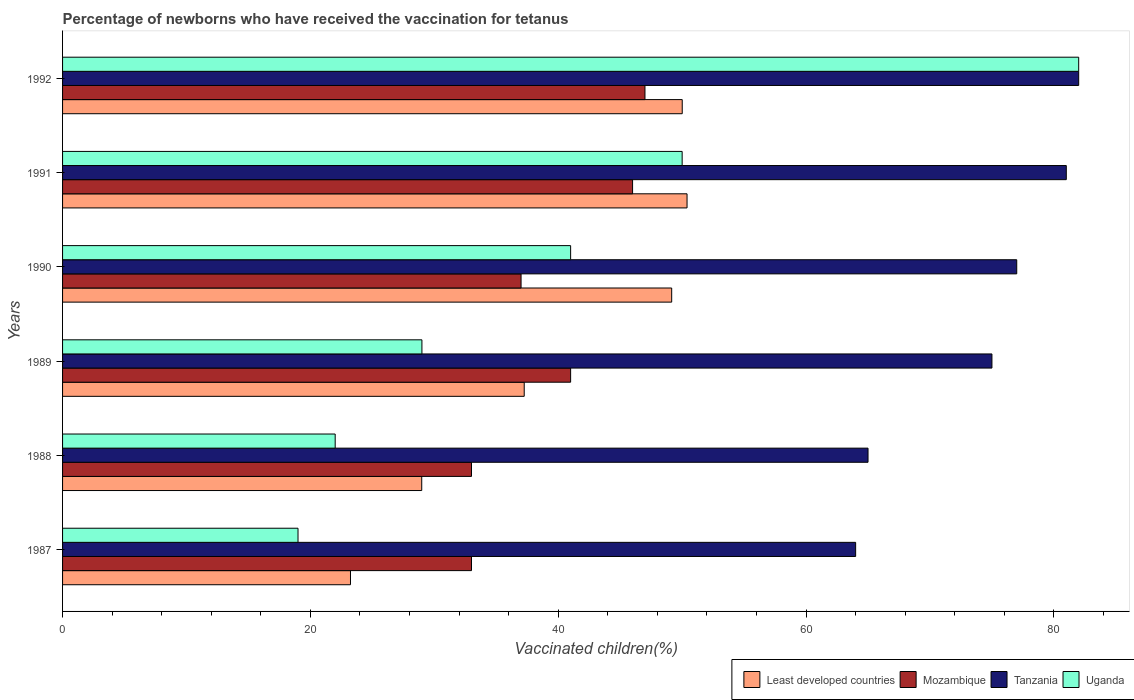Are the number of bars per tick equal to the number of legend labels?
Provide a short and direct response. Yes. Are the number of bars on each tick of the Y-axis equal?
Provide a succinct answer. Yes. How many bars are there on the 2nd tick from the bottom?
Make the answer very short. 4. What is the percentage of vaccinated children in Mozambique in 1988?
Offer a very short reply. 33. Across all years, what is the maximum percentage of vaccinated children in Least developed countries?
Provide a short and direct response. 50.39. Across all years, what is the minimum percentage of vaccinated children in Least developed countries?
Make the answer very short. 23.23. What is the total percentage of vaccinated children in Tanzania in the graph?
Keep it short and to the point. 444. What is the difference between the percentage of vaccinated children in Least developed countries in 1988 and that in 1989?
Keep it short and to the point. -8.27. What is the difference between the percentage of vaccinated children in Tanzania in 1988 and the percentage of vaccinated children in Least developed countries in 1989?
Give a very brief answer. 27.75. What is the average percentage of vaccinated children in Least developed countries per year?
Provide a succinct answer. 39.84. In the year 1990, what is the difference between the percentage of vaccinated children in Mozambique and percentage of vaccinated children in Uganda?
Provide a short and direct response. -4. What is the ratio of the percentage of vaccinated children in Mozambique in 1988 to that in 1992?
Offer a very short reply. 0.7. Is the percentage of vaccinated children in Tanzania in 1987 less than that in 1992?
Your answer should be compact. Yes. Is the difference between the percentage of vaccinated children in Mozambique in 1988 and 1992 greater than the difference between the percentage of vaccinated children in Uganda in 1988 and 1992?
Provide a short and direct response. Yes. What is the difference between the highest and the second highest percentage of vaccinated children in Least developed countries?
Provide a succinct answer. 0.39. What is the difference between the highest and the lowest percentage of vaccinated children in Tanzania?
Offer a terse response. 18. Is the sum of the percentage of vaccinated children in Uganda in 1990 and 1992 greater than the maximum percentage of vaccinated children in Tanzania across all years?
Your response must be concise. Yes. What does the 2nd bar from the top in 1990 represents?
Provide a succinct answer. Tanzania. What does the 3rd bar from the bottom in 1990 represents?
Your answer should be very brief. Tanzania. Is it the case that in every year, the sum of the percentage of vaccinated children in Tanzania and percentage of vaccinated children in Mozambique is greater than the percentage of vaccinated children in Least developed countries?
Provide a short and direct response. Yes. How many bars are there?
Your answer should be very brief. 24. How many legend labels are there?
Your answer should be very brief. 4. What is the title of the graph?
Offer a terse response. Percentage of newborns who have received the vaccination for tetanus. Does "Faeroe Islands" appear as one of the legend labels in the graph?
Ensure brevity in your answer.  No. What is the label or title of the X-axis?
Ensure brevity in your answer.  Vaccinated children(%). What is the Vaccinated children(%) of Least developed countries in 1987?
Offer a terse response. 23.23. What is the Vaccinated children(%) in Mozambique in 1987?
Your answer should be very brief. 33. What is the Vaccinated children(%) in Tanzania in 1987?
Provide a succinct answer. 64. What is the Vaccinated children(%) in Least developed countries in 1988?
Provide a short and direct response. 28.98. What is the Vaccinated children(%) of Mozambique in 1988?
Provide a short and direct response. 33. What is the Vaccinated children(%) in Tanzania in 1988?
Your response must be concise. 65. What is the Vaccinated children(%) of Least developed countries in 1989?
Ensure brevity in your answer.  37.25. What is the Vaccinated children(%) of Tanzania in 1989?
Make the answer very short. 75. What is the Vaccinated children(%) in Least developed countries in 1990?
Give a very brief answer. 49.16. What is the Vaccinated children(%) of Mozambique in 1990?
Your response must be concise. 37. What is the Vaccinated children(%) in Tanzania in 1990?
Make the answer very short. 77. What is the Vaccinated children(%) of Uganda in 1990?
Your response must be concise. 41. What is the Vaccinated children(%) in Least developed countries in 1991?
Ensure brevity in your answer.  50.39. What is the Vaccinated children(%) of Mozambique in 1991?
Your response must be concise. 46. What is the Vaccinated children(%) in Tanzania in 1991?
Provide a short and direct response. 81. What is the Vaccinated children(%) of Uganda in 1991?
Your answer should be compact. 50. What is the Vaccinated children(%) of Least developed countries in 1992?
Give a very brief answer. 50.01. What is the Vaccinated children(%) in Mozambique in 1992?
Ensure brevity in your answer.  47. What is the Vaccinated children(%) in Tanzania in 1992?
Ensure brevity in your answer.  82. Across all years, what is the maximum Vaccinated children(%) of Least developed countries?
Your response must be concise. 50.39. Across all years, what is the maximum Vaccinated children(%) of Mozambique?
Your response must be concise. 47. Across all years, what is the maximum Vaccinated children(%) of Tanzania?
Offer a very short reply. 82. Across all years, what is the minimum Vaccinated children(%) in Least developed countries?
Your response must be concise. 23.23. Across all years, what is the minimum Vaccinated children(%) of Mozambique?
Offer a terse response. 33. Across all years, what is the minimum Vaccinated children(%) of Tanzania?
Your answer should be compact. 64. What is the total Vaccinated children(%) in Least developed countries in the graph?
Ensure brevity in your answer.  239.03. What is the total Vaccinated children(%) of Mozambique in the graph?
Offer a terse response. 237. What is the total Vaccinated children(%) in Tanzania in the graph?
Offer a terse response. 444. What is the total Vaccinated children(%) in Uganda in the graph?
Provide a succinct answer. 243. What is the difference between the Vaccinated children(%) of Least developed countries in 1987 and that in 1988?
Offer a terse response. -5.75. What is the difference between the Vaccinated children(%) of Mozambique in 1987 and that in 1988?
Your response must be concise. 0. What is the difference between the Vaccinated children(%) of Tanzania in 1987 and that in 1988?
Make the answer very short. -1. What is the difference between the Vaccinated children(%) of Least developed countries in 1987 and that in 1989?
Your answer should be compact. -14.02. What is the difference between the Vaccinated children(%) in Uganda in 1987 and that in 1989?
Provide a short and direct response. -10. What is the difference between the Vaccinated children(%) of Least developed countries in 1987 and that in 1990?
Make the answer very short. -25.92. What is the difference between the Vaccinated children(%) in Uganda in 1987 and that in 1990?
Make the answer very short. -22. What is the difference between the Vaccinated children(%) in Least developed countries in 1987 and that in 1991?
Provide a succinct answer. -27.16. What is the difference between the Vaccinated children(%) of Mozambique in 1987 and that in 1991?
Provide a short and direct response. -13. What is the difference between the Vaccinated children(%) in Tanzania in 1987 and that in 1991?
Your response must be concise. -17. What is the difference between the Vaccinated children(%) in Uganda in 1987 and that in 1991?
Make the answer very short. -31. What is the difference between the Vaccinated children(%) of Least developed countries in 1987 and that in 1992?
Ensure brevity in your answer.  -26.77. What is the difference between the Vaccinated children(%) of Mozambique in 1987 and that in 1992?
Give a very brief answer. -14. What is the difference between the Vaccinated children(%) of Tanzania in 1987 and that in 1992?
Your answer should be compact. -18. What is the difference between the Vaccinated children(%) in Uganda in 1987 and that in 1992?
Ensure brevity in your answer.  -63. What is the difference between the Vaccinated children(%) of Least developed countries in 1988 and that in 1989?
Keep it short and to the point. -8.27. What is the difference between the Vaccinated children(%) in Least developed countries in 1988 and that in 1990?
Make the answer very short. -20.17. What is the difference between the Vaccinated children(%) in Least developed countries in 1988 and that in 1991?
Ensure brevity in your answer.  -21.41. What is the difference between the Vaccinated children(%) of Mozambique in 1988 and that in 1991?
Offer a terse response. -13. What is the difference between the Vaccinated children(%) of Tanzania in 1988 and that in 1991?
Provide a short and direct response. -16. What is the difference between the Vaccinated children(%) in Uganda in 1988 and that in 1991?
Ensure brevity in your answer.  -28. What is the difference between the Vaccinated children(%) in Least developed countries in 1988 and that in 1992?
Provide a short and direct response. -21.02. What is the difference between the Vaccinated children(%) in Uganda in 1988 and that in 1992?
Your answer should be very brief. -60. What is the difference between the Vaccinated children(%) of Least developed countries in 1989 and that in 1990?
Keep it short and to the point. -11.9. What is the difference between the Vaccinated children(%) of Tanzania in 1989 and that in 1990?
Offer a very short reply. -2. What is the difference between the Vaccinated children(%) of Least developed countries in 1989 and that in 1991?
Offer a terse response. -13.14. What is the difference between the Vaccinated children(%) of Tanzania in 1989 and that in 1991?
Your response must be concise. -6. What is the difference between the Vaccinated children(%) of Least developed countries in 1989 and that in 1992?
Provide a short and direct response. -12.75. What is the difference between the Vaccinated children(%) of Mozambique in 1989 and that in 1992?
Provide a short and direct response. -6. What is the difference between the Vaccinated children(%) in Uganda in 1989 and that in 1992?
Ensure brevity in your answer.  -53. What is the difference between the Vaccinated children(%) of Least developed countries in 1990 and that in 1991?
Provide a succinct answer. -1.24. What is the difference between the Vaccinated children(%) of Mozambique in 1990 and that in 1991?
Give a very brief answer. -9. What is the difference between the Vaccinated children(%) of Tanzania in 1990 and that in 1991?
Your answer should be compact. -4. What is the difference between the Vaccinated children(%) in Least developed countries in 1990 and that in 1992?
Your answer should be very brief. -0.85. What is the difference between the Vaccinated children(%) of Mozambique in 1990 and that in 1992?
Ensure brevity in your answer.  -10. What is the difference between the Vaccinated children(%) of Uganda in 1990 and that in 1992?
Offer a very short reply. -41. What is the difference between the Vaccinated children(%) in Least developed countries in 1991 and that in 1992?
Your response must be concise. 0.39. What is the difference between the Vaccinated children(%) in Tanzania in 1991 and that in 1992?
Make the answer very short. -1. What is the difference between the Vaccinated children(%) in Uganda in 1991 and that in 1992?
Ensure brevity in your answer.  -32. What is the difference between the Vaccinated children(%) in Least developed countries in 1987 and the Vaccinated children(%) in Mozambique in 1988?
Ensure brevity in your answer.  -9.77. What is the difference between the Vaccinated children(%) in Least developed countries in 1987 and the Vaccinated children(%) in Tanzania in 1988?
Offer a very short reply. -41.77. What is the difference between the Vaccinated children(%) of Least developed countries in 1987 and the Vaccinated children(%) of Uganda in 1988?
Provide a succinct answer. 1.23. What is the difference between the Vaccinated children(%) in Mozambique in 1987 and the Vaccinated children(%) in Tanzania in 1988?
Your response must be concise. -32. What is the difference between the Vaccinated children(%) of Mozambique in 1987 and the Vaccinated children(%) of Uganda in 1988?
Your response must be concise. 11. What is the difference between the Vaccinated children(%) in Tanzania in 1987 and the Vaccinated children(%) in Uganda in 1988?
Make the answer very short. 42. What is the difference between the Vaccinated children(%) in Least developed countries in 1987 and the Vaccinated children(%) in Mozambique in 1989?
Your response must be concise. -17.77. What is the difference between the Vaccinated children(%) in Least developed countries in 1987 and the Vaccinated children(%) in Tanzania in 1989?
Provide a short and direct response. -51.77. What is the difference between the Vaccinated children(%) of Least developed countries in 1987 and the Vaccinated children(%) of Uganda in 1989?
Offer a terse response. -5.77. What is the difference between the Vaccinated children(%) of Mozambique in 1987 and the Vaccinated children(%) of Tanzania in 1989?
Provide a short and direct response. -42. What is the difference between the Vaccinated children(%) of Least developed countries in 1987 and the Vaccinated children(%) of Mozambique in 1990?
Provide a succinct answer. -13.77. What is the difference between the Vaccinated children(%) in Least developed countries in 1987 and the Vaccinated children(%) in Tanzania in 1990?
Offer a very short reply. -53.77. What is the difference between the Vaccinated children(%) of Least developed countries in 1987 and the Vaccinated children(%) of Uganda in 1990?
Offer a terse response. -17.77. What is the difference between the Vaccinated children(%) of Mozambique in 1987 and the Vaccinated children(%) of Tanzania in 1990?
Make the answer very short. -44. What is the difference between the Vaccinated children(%) in Mozambique in 1987 and the Vaccinated children(%) in Uganda in 1990?
Keep it short and to the point. -8. What is the difference between the Vaccinated children(%) in Tanzania in 1987 and the Vaccinated children(%) in Uganda in 1990?
Provide a succinct answer. 23. What is the difference between the Vaccinated children(%) in Least developed countries in 1987 and the Vaccinated children(%) in Mozambique in 1991?
Provide a succinct answer. -22.77. What is the difference between the Vaccinated children(%) in Least developed countries in 1987 and the Vaccinated children(%) in Tanzania in 1991?
Offer a terse response. -57.77. What is the difference between the Vaccinated children(%) of Least developed countries in 1987 and the Vaccinated children(%) of Uganda in 1991?
Offer a terse response. -26.77. What is the difference between the Vaccinated children(%) of Mozambique in 1987 and the Vaccinated children(%) of Tanzania in 1991?
Make the answer very short. -48. What is the difference between the Vaccinated children(%) in Mozambique in 1987 and the Vaccinated children(%) in Uganda in 1991?
Provide a short and direct response. -17. What is the difference between the Vaccinated children(%) in Tanzania in 1987 and the Vaccinated children(%) in Uganda in 1991?
Make the answer very short. 14. What is the difference between the Vaccinated children(%) of Least developed countries in 1987 and the Vaccinated children(%) of Mozambique in 1992?
Your response must be concise. -23.77. What is the difference between the Vaccinated children(%) in Least developed countries in 1987 and the Vaccinated children(%) in Tanzania in 1992?
Make the answer very short. -58.77. What is the difference between the Vaccinated children(%) in Least developed countries in 1987 and the Vaccinated children(%) in Uganda in 1992?
Offer a terse response. -58.77. What is the difference between the Vaccinated children(%) in Mozambique in 1987 and the Vaccinated children(%) in Tanzania in 1992?
Offer a very short reply. -49. What is the difference between the Vaccinated children(%) in Mozambique in 1987 and the Vaccinated children(%) in Uganda in 1992?
Keep it short and to the point. -49. What is the difference between the Vaccinated children(%) of Least developed countries in 1988 and the Vaccinated children(%) of Mozambique in 1989?
Your answer should be compact. -12.02. What is the difference between the Vaccinated children(%) in Least developed countries in 1988 and the Vaccinated children(%) in Tanzania in 1989?
Offer a very short reply. -46.02. What is the difference between the Vaccinated children(%) in Least developed countries in 1988 and the Vaccinated children(%) in Uganda in 1989?
Provide a succinct answer. -0.02. What is the difference between the Vaccinated children(%) of Mozambique in 1988 and the Vaccinated children(%) of Tanzania in 1989?
Ensure brevity in your answer.  -42. What is the difference between the Vaccinated children(%) in Least developed countries in 1988 and the Vaccinated children(%) in Mozambique in 1990?
Provide a short and direct response. -8.02. What is the difference between the Vaccinated children(%) in Least developed countries in 1988 and the Vaccinated children(%) in Tanzania in 1990?
Your answer should be very brief. -48.02. What is the difference between the Vaccinated children(%) in Least developed countries in 1988 and the Vaccinated children(%) in Uganda in 1990?
Provide a succinct answer. -12.02. What is the difference between the Vaccinated children(%) in Mozambique in 1988 and the Vaccinated children(%) in Tanzania in 1990?
Keep it short and to the point. -44. What is the difference between the Vaccinated children(%) in Tanzania in 1988 and the Vaccinated children(%) in Uganda in 1990?
Provide a short and direct response. 24. What is the difference between the Vaccinated children(%) in Least developed countries in 1988 and the Vaccinated children(%) in Mozambique in 1991?
Make the answer very short. -17.02. What is the difference between the Vaccinated children(%) in Least developed countries in 1988 and the Vaccinated children(%) in Tanzania in 1991?
Your answer should be very brief. -52.02. What is the difference between the Vaccinated children(%) of Least developed countries in 1988 and the Vaccinated children(%) of Uganda in 1991?
Keep it short and to the point. -21.02. What is the difference between the Vaccinated children(%) of Mozambique in 1988 and the Vaccinated children(%) of Tanzania in 1991?
Offer a very short reply. -48. What is the difference between the Vaccinated children(%) of Mozambique in 1988 and the Vaccinated children(%) of Uganda in 1991?
Offer a terse response. -17. What is the difference between the Vaccinated children(%) of Tanzania in 1988 and the Vaccinated children(%) of Uganda in 1991?
Your answer should be very brief. 15. What is the difference between the Vaccinated children(%) in Least developed countries in 1988 and the Vaccinated children(%) in Mozambique in 1992?
Your answer should be very brief. -18.02. What is the difference between the Vaccinated children(%) of Least developed countries in 1988 and the Vaccinated children(%) of Tanzania in 1992?
Offer a terse response. -53.02. What is the difference between the Vaccinated children(%) of Least developed countries in 1988 and the Vaccinated children(%) of Uganda in 1992?
Offer a very short reply. -53.02. What is the difference between the Vaccinated children(%) of Mozambique in 1988 and the Vaccinated children(%) of Tanzania in 1992?
Your response must be concise. -49. What is the difference between the Vaccinated children(%) of Mozambique in 1988 and the Vaccinated children(%) of Uganda in 1992?
Ensure brevity in your answer.  -49. What is the difference between the Vaccinated children(%) of Least developed countries in 1989 and the Vaccinated children(%) of Mozambique in 1990?
Offer a very short reply. 0.25. What is the difference between the Vaccinated children(%) in Least developed countries in 1989 and the Vaccinated children(%) in Tanzania in 1990?
Provide a short and direct response. -39.75. What is the difference between the Vaccinated children(%) of Least developed countries in 1989 and the Vaccinated children(%) of Uganda in 1990?
Make the answer very short. -3.75. What is the difference between the Vaccinated children(%) in Mozambique in 1989 and the Vaccinated children(%) in Tanzania in 1990?
Ensure brevity in your answer.  -36. What is the difference between the Vaccinated children(%) of Mozambique in 1989 and the Vaccinated children(%) of Uganda in 1990?
Offer a very short reply. 0. What is the difference between the Vaccinated children(%) in Least developed countries in 1989 and the Vaccinated children(%) in Mozambique in 1991?
Your answer should be very brief. -8.75. What is the difference between the Vaccinated children(%) of Least developed countries in 1989 and the Vaccinated children(%) of Tanzania in 1991?
Provide a succinct answer. -43.75. What is the difference between the Vaccinated children(%) of Least developed countries in 1989 and the Vaccinated children(%) of Uganda in 1991?
Offer a terse response. -12.75. What is the difference between the Vaccinated children(%) of Mozambique in 1989 and the Vaccinated children(%) of Tanzania in 1991?
Give a very brief answer. -40. What is the difference between the Vaccinated children(%) of Mozambique in 1989 and the Vaccinated children(%) of Uganda in 1991?
Your response must be concise. -9. What is the difference between the Vaccinated children(%) of Least developed countries in 1989 and the Vaccinated children(%) of Mozambique in 1992?
Provide a short and direct response. -9.75. What is the difference between the Vaccinated children(%) of Least developed countries in 1989 and the Vaccinated children(%) of Tanzania in 1992?
Keep it short and to the point. -44.75. What is the difference between the Vaccinated children(%) in Least developed countries in 1989 and the Vaccinated children(%) in Uganda in 1992?
Give a very brief answer. -44.75. What is the difference between the Vaccinated children(%) of Mozambique in 1989 and the Vaccinated children(%) of Tanzania in 1992?
Give a very brief answer. -41. What is the difference between the Vaccinated children(%) in Mozambique in 1989 and the Vaccinated children(%) in Uganda in 1992?
Offer a terse response. -41. What is the difference between the Vaccinated children(%) in Tanzania in 1989 and the Vaccinated children(%) in Uganda in 1992?
Your response must be concise. -7. What is the difference between the Vaccinated children(%) in Least developed countries in 1990 and the Vaccinated children(%) in Mozambique in 1991?
Ensure brevity in your answer.  3.16. What is the difference between the Vaccinated children(%) of Least developed countries in 1990 and the Vaccinated children(%) of Tanzania in 1991?
Offer a terse response. -31.84. What is the difference between the Vaccinated children(%) of Least developed countries in 1990 and the Vaccinated children(%) of Uganda in 1991?
Give a very brief answer. -0.84. What is the difference between the Vaccinated children(%) of Mozambique in 1990 and the Vaccinated children(%) of Tanzania in 1991?
Give a very brief answer. -44. What is the difference between the Vaccinated children(%) of Tanzania in 1990 and the Vaccinated children(%) of Uganda in 1991?
Give a very brief answer. 27. What is the difference between the Vaccinated children(%) in Least developed countries in 1990 and the Vaccinated children(%) in Mozambique in 1992?
Provide a short and direct response. 2.16. What is the difference between the Vaccinated children(%) of Least developed countries in 1990 and the Vaccinated children(%) of Tanzania in 1992?
Offer a very short reply. -32.84. What is the difference between the Vaccinated children(%) of Least developed countries in 1990 and the Vaccinated children(%) of Uganda in 1992?
Offer a terse response. -32.84. What is the difference between the Vaccinated children(%) of Mozambique in 1990 and the Vaccinated children(%) of Tanzania in 1992?
Provide a succinct answer. -45. What is the difference between the Vaccinated children(%) in Mozambique in 1990 and the Vaccinated children(%) in Uganda in 1992?
Provide a short and direct response. -45. What is the difference between the Vaccinated children(%) in Least developed countries in 1991 and the Vaccinated children(%) in Mozambique in 1992?
Provide a succinct answer. 3.39. What is the difference between the Vaccinated children(%) in Least developed countries in 1991 and the Vaccinated children(%) in Tanzania in 1992?
Make the answer very short. -31.61. What is the difference between the Vaccinated children(%) in Least developed countries in 1991 and the Vaccinated children(%) in Uganda in 1992?
Make the answer very short. -31.61. What is the difference between the Vaccinated children(%) of Mozambique in 1991 and the Vaccinated children(%) of Tanzania in 1992?
Offer a terse response. -36. What is the difference between the Vaccinated children(%) of Mozambique in 1991 and the Vaccinated children(%) of Uganda in 1992?
Ensure brevity in your answer.  -36. What is the average Vaccinated children(%) of Least developed countries per year?
Give a very brief answer. 39.84. What is the average Vaccinated children(%) of Mozambique per year?
Give a very brief answer. 39.5. What is the average Vaccinated children(%) in Tanzania per year?
Ensure brevity in your answer.  74. What is the average Vaccinated children(%) in Uganda per year?
Ensure brevity in your answer.  40.5. In the year 1987, what is the difference between the Vaccinated children(%) of Least developed countries and Vaccinated children(%) of Mozambique?
Your response must be concise. -9.77. In the year 1987, what is the difference between the Vaccinated children(%) of Least developed countries and Vaccinated children(%) of Tanzania?
Your answer should be compact. -40.77. In the year 1987, what is the difference between the Vaccinated children(%) of Least developed countries and Vaccinated children(%) of Uganda?
Your answer should be compact. 4.23. In the year 1987, what is the difference between the Vaccinated children(%) in Mozambique and Vaccinated children(%) in Tanzania?
Offer a terse response. -31. In the year 1987, what is the difference between the Vaccinated children(%) of Tanzania and Vaccinated children(%) of Uganda?
Ensure brevity in your answer.  45. In the year 1988, what is the difference between the Vaccinated children(%) of Least developed countries and Vaccinated children(%) of Mozambique?
Offer a terse response. -4.02. In the year 1988, what is the difference between the Vaccinated children(%) in Least developed countries and Vaccinated children(%) in Tanzania?
Keep it short and to the point. -36.02. In the year 1988, what is the difference between the Vaccinated children(%) of Least developed countries and Vaccinated children(%) of Uganda?
Provide a short and direct response. 6.98. In the year 1988, what is the difference between the Vaccinated children(%) in Mozambique and Vaccinated children(%) in Tanzania?
Provide a short and direct response. -32. In the year 1988, what is the difference between the Vaccinated children(%) in Mozambique and Vaccinated children(%) in Uganda?
Keep it short and to the point. 11. In the year 1989, what is the difference between the Vaccinated children(%) in Least developed countries and Vaccinated children(%) in Mozambique?
Your answer should be very brief. -3.75. In the year 1989, what is the difference between the Vaccinated children(%) in Least developed countries and Vaccinated children(%) in Tanzania?
Keep it short and to the point. -37.75. In the year 1989, what is the difference between the Vaccinated children(%) in Least developed countries and Vaccinated children(%) in Uganda?
Your answer should be compact. 8.25. In the year 1989, what is the difference between the Vaccinated children(%) of Mozambique and Vaccinated children(%) of Tanzania?
Provide a succinct answer. -34. In the year 1990, what is the difference between the Vaccinated children(%) in Least developed countries and Vaccinated children(%) in Mozambique?
Offer a very short reply. 12.16. In the year 1990, what is the difference between the Vaccinated children(%) of Least developed countries and Vaccinated children(%) of Tanzania?
Ensure brevity in your answer.  -27.84. In the year 1990, what is the difference between the Vaccinated children(%) of Least developed countries and Vaccinated children(%) of Uganda?
Offer a very short reply. 8.16. In the year 1990, what is the difference between the Vaccinated children(%) in Mozambique and Vaccinated children(%) in Tanzania?
Your answer should be compact. -40. In the year 1990, what is the difference between the Vaccinated children(%) in Tanzania and Vaccinated children(%) in Uganda?
Your answer should be very brief. 36. In the year 1991, what is the difference between the Vaccinated children(%) in Least developed countries and Vaccinated children(%) in Mozambique?
Make the answer very short. 4.39. In the year 1991, what is the difference between the Vaccinated children(%) of Least developed countries and Vaccinated children(%) of Tanzania?
Make the answer very short. -30.61. In the year 1991, what is the difference between the Vaccinated children(%) in Least developed countries and Vaccinated children(%) in Uganda?
Offer a very short reply. 0.39. In the year 1991, what is the difference between the Vaccinated children(%) in Mozambique and Vaccinated children(%) in Tanzania?
Ensure brevity in your answer.  -35. In the year 1991, what is the difference between the Vaccinated children(%) in Mozambique and Vaccinated children(%) in Uganda?
Keep it short and to the point. -4. In the year 1992, what is the difference between the Vaccinated children(%) in Least developed countries and Vaccinated children(%) in Mozambique?
Your response must be concise. 3.01. In the year 1992, what is the difference between the Vaccinated children(%) in Least developed countries and Vaccinated children(%) in Tanzania?
Provide a short and direct response. -31.99. In the year 1992, what is the difference between the Vaccinated children(%) of Least developed countries and Vaccinated children(%) of Uganda?
Your response must be concise. -31.99. In the year 1992, what is the difference between the Vaccinated children(%) of Mozambique and Vaccinated children(%) of Tanzania?
Your answer should be compact. -35. In the year 1992, what is the difference between the Vaccinated children(%) of Mozambique and Vaccinated children(%) of Uganda?
Offer a terse response. -35. What is the ratio of the Vaccinated children(%) in Least developed countries in 1987 to that in 1988?
Ensure brevity in your answer.  0.8. What is the ratio of the Vaccinated children(%) of Mozambique in 1987 to that in 1988?
Your answer should be very brief. 1. What is the ratio of the Vaccinated children(%) in Tanzania in 1987 to that in 1988?
Your answer should be compact. 0.98. What is the ratio of the Vaccinated children(%) in Uganda in 1987 to that in 1988?
Offer a very short reply. 0.86. What is the ratio of the Vaccinated children(%) in Least developed countries in 1987 to that in 1989?
Your response must be concise. 0.62. What is the ratio of the Vaccinated children(%) of Mozambique in 1987 to that in 1989?
Offer a terse response. 0.8. What is the ratio of the Vaccinated children(%) of Tanzania in 1987 to that in 1989?
Give a very brief answer. 0.85. What is the ratio of the Vaccinated children(%) of Uganda in 1987 to that in 1989?
Provide a short and direct response. 0.66. What is the ratio of the Vaccinated children(%) in Least developed countries in 1987 to that in 1990?
Provide a short and direct response. 0.47. What is the ratio of the Vaccinated children(%) of Mozambique in 1987 to that in 1990?
Your answer should be very brief. 0.89. What is the ratio of the Vaccinated children(%) in Tanzania in 1987 to that in 1990?
Your answer should be compact. 0.83. What is the ratio of the Vaccinated children(%) in Uganda in 1987 to that in 1990?
Provide a succinct answer. 0.46. What is the ratio of the Vaccinated children(%) of Least developed countries in 1987 to that in 1991?
Your answer should be very brief. 0.46. What is the ratio of the Vaccinated children(%) of Mozambique in 1987 to that in 1991?
Your answer should be very brief. 0.72. What is the ratio of the Vaccinated children(%) in Tanzania in 1987 to that in 1991?
Offer a very short reply. 0.79. What is the ratio of the Vaccinated children(%) of Uganda in 1987 to that in 1991?
Keep it short and to the point. 0.38. What is the ratio of the Vaccinated children(%) in Least developed countries in 1987 to that in 1992?
Your answer should be very brief. 0.46. What is the ratio of the Vaccinated children(%) of Mozambique in 1987 to that in 1992?
Provide a short and direct response. 0.7. What is the ratio of the Vaccinated children(%) in Tanzania in 1987 to that in 1992?
Make the answer very short. 0.78. What is the ratio of the Vaccinated children(%) of Uganda in 1987 to that in 1992?
Provide a short and direct response. 0.23. What is the ratio of the Vaccinated children(%) of Least developed countries in 1988 to that in 1989?
Your response must be concise. 0.78. What is the ratio of the Vaccinated children(%) in Mozambique in 1988 to that in 1989?
Your response must be concise. 0.8. What is the ratio of the Vaccinated children(%) in Tanzania in 1988 to that in 1989?
Offer a terse response. 0.87. What is the ratio of the Vaccinated children(%) in Uganda in 1988 to that in 1989?
Your response must be concise. 0.76. What is the ratio of the Vaccinated children(%) of Least developed countries in 1988 to that in 1990?
Your answer should be compact. 0.59. What is the ratio of the Vaccinated children(%) of Mozambique in 1988 to that in 1990?
Offer a terse response. 0.89. What is the ratio of the Vaccinated children(%) of Tanzania in 1988 to that in 1990?
Give a very brief answer. 0.84. What is the ratio of the Vaccinated children(%) in Uganda in 1988 to that in 1990?
Provide a short and direct response. 0.54. What is the ratio of the Vaccinated children(%) of Least developed countries in 1988 to that in 1991?
Provide a succinct answer. 0.58. What is the ratio of the Vaccinated children(%) in Mozambique in 1988 to that in 1991?
Offer a terse response. 0.72. What is the ratio of the Vaccinated children(%) in Tanzania in 1988 to that in 1991?
Keep it short and to the point. 0.8. What is the ratio of the Vaccinated children(%) in Uganda in 1988 to that in 1991?
Provide a short and direct response. 0.44. What is the ratio of the Vaccinated children(%) in Least developed countries in 1988 to that in 1992?
Keep it short and to the point. 0.58. What is the ratio of the Vaccinated children(%) in Mozambique in 1988 to that in 1992?
Your answer should be compact. 0.7. What is the ratio of the Vaccinated children(%) in Tanzania in 1988 to that in 1992?
Keep it short and to the point. 0.79. What is the ratio of the Vaccinated children(%) in Uganda in 1988 to that in 1992?
Provide a short and direct response. 0.27. What is the ratio of the Vaccinated children(%) of Least developed countries in 1989 to that in 1990?
Your answer should be very brief. 0.76. What is the ratio of the Vaccinated children(%) of Mozambique in 1989 to that in 1990?
Give a very brief answer. 1.11. What is the ratio of the Vaccinated children(%) in Uganda in 1989 to that in 1990?
Offer a terse response. 0.71. What is the ratio of the Vaccinated children(%) of Least developed countries in 1989 to that in 1991?
Make the answer very short. 0.74. What is the ratio of the Vaccinated children(%) in Mozambique in 1989 to that in 1991?
Ensure brevity in your answer.  0.89. What is the ratio of the Vaccinated children(%) in Tanzania in 1989 to that in 1991?
Provide a short and direct response. 0.93. What is the ratio of the Vaccinated children(%) in Uganda in 1989 to that in 1991?
Offer a very short reply. 0.58. What is the ratio of the Vaccinated children(%) in Least developed countries in 1989 to that in 1992?
Your answer should be compact. 0.74. What is the ratio of the Vaccinated children(%) in Mozambique in 1989 to that in 1992?
Make the answer very short. 0.87. What is the ratio of the Vaccinated children(%) of Tanzania in 1989 to that in 1992?
Your answer should be compact. 0.91. What is the ratio of the Vaccinated children(%) of Uganda in 1989 to that in 1992?
Provide a short and direct response. 0.35. What is the ratio of the Vaccinated children(%) of Least developed countries in 1990 to that in 1991?
Keep it short and to the point. 0.98. What is the ratio of the Vaccinated children(%) of Mozambique in 1990 to that in 1991?
Ensure brevity in your answer.  0.8. What is the ratio of the Vaccinated children(%) of Tanzania in 1990 to that in 1991?
Your answer should be compact. 0.95. What is the ratio of the Vaccinated children(%) in Uganda in 1990 to that in 1991?
Provide a short and direct response. 0.82. What is the ratio of the Vaccinated children(%) in Mozambique in 1990 to that in 1992?
Keep it short and to the point. 0.79. What is the ratio of the Vaccinated children(%) in Tanzania in 1990 to that in 1992?
Your answer should be compact. 0.94. What is the ratio of the Vaccinated children(%) in Least developed countries in 1991 to that in 1992?
Your answer should be very brief. 1.01. What is the ratio of the Vaccinated children(%) in Mozambique in 1991 to that in 1992?
Keep it short and to the point. 0.98. What is the ratio of the Vaccinated children(%) of Uganda in 1991 to that in 1992?
Your answer should be compact. 0.61. What is the difference between the highest and the second highest Vaccinated children(%) of Least developed countries?
Provide a succinct answer. 0.39. What is the difference between the highest and the second highest Vaccinated children(%) in Mozambique?
Offer a terse response. 1. What is the difference between the highest and the lowest Vaccinated children(%) of Least developed countries?
Keep it short and to the point. 27.16. What is the difference between the highest and the lowest Vaccinated children(%) in Tanzania?
Provide a short and direct response. 18. 